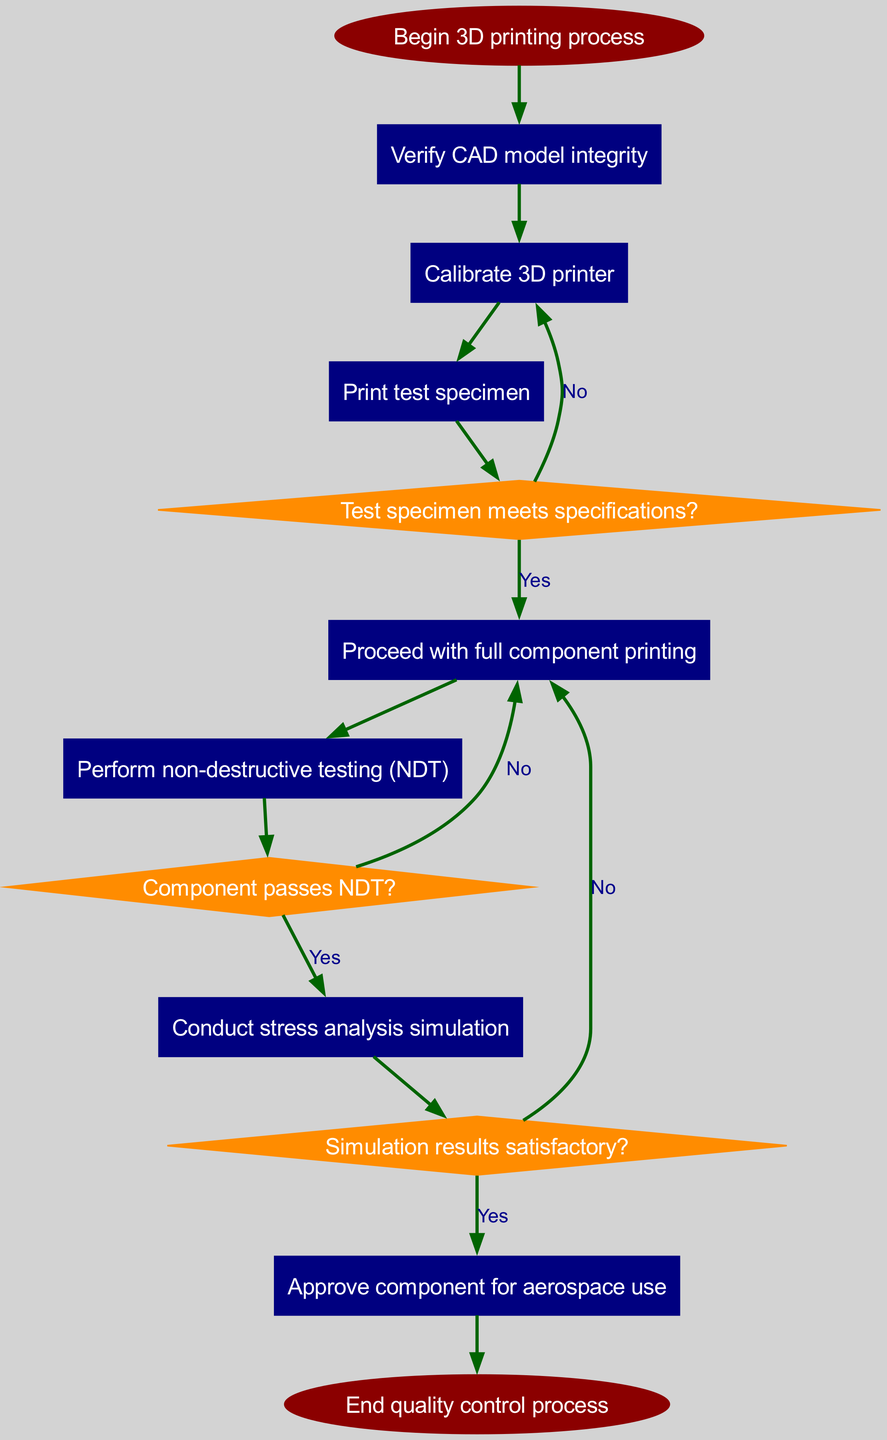What is the first step in the quality control process? The diagram starts with the node labeled "Begin 3D printing process," indicating that this is the first step of the process.
Answer: Begin 3D printing process How many decision nodes are present in the diagram? By examining the diagram, we can identify that there are three nodes labeled as decisions, which are "Test specimen meets specifications?", "Component passes NDT?", and "Simulation results satisfactory?"
Answer: 3 What needs to be verified before calibrating the 3D printer? According to the flow, the first action "Verify CAD model integrity" must be completed before proceeding to "Calibrate 3D printer."
Answer: Verify CAD model integrity If the test specimen does not meet specifications, which step is taken next? Following the decision "Test specimen meets specifications?" with a "No" outcome, the flow leads back to "Calibrate 3D printer," indicating that recalibration is the next step.
Answer: Calibrate 3D printer What happens if the component fails the non-destructive testing? The failure at "Component passes NDT?" with a "No" outcome leads back to "Proceed with full component printing," thus indicating a return to the previous step.
Answer: Proceed with full component printing How many steps must be completed after the test specimen is printed to approve the component for aerospace use? The flow shows that after printing the test specimen, there are four steps to complete before “Approve component for aerospace use”: "Perform NDT", "Conduct stress analysis simulation", and then the three decisions before the approval step.
Answer: 4 What is the final outcome of the quality control process? The last node of the diagram indicates "End quality control process," which signifies the conclusion of the entire process flow.
Answer: End quality control process If the simulation results are not satisfactory, what does the process recommend? If the decision "Simulation results satisfactory?" is answered "No", the process loops back to the step "Proceed with full component printing", indicating that prior steps need to be revisited.
Answer: Proceed with full component printing Which step involves testing the printed component's integrity without causing damage? The step identified as "Perform non-destructive testing (NDT)" focuses specifically on assessing the component's integrity while avoiding any damage to it.
Answer: Perform non-destructive testing (NDT) 